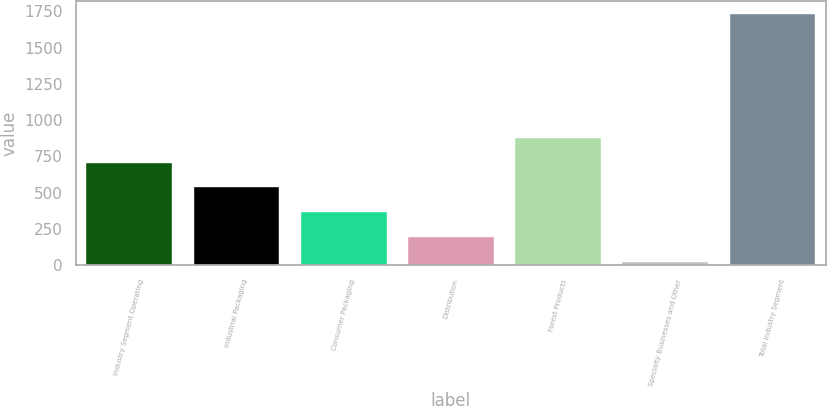Convert chart. <chart><loc_0><loc_0><loc_500><loc_500><bar_chart><fcel>Industry Segment Operating<fcel>Industrial Packaging<fcel>Consumer Packaging<fcel>Distribution<fcel>Forest Products<fcel>Specialty Businesses and Other<fcel>Total Industry Segment<nl><fcel>707.4<fcel>536.3<fcel>365.2<fcel>194.1<fcel>878.5<fcel>23<fcel>1734<nl></chart> 